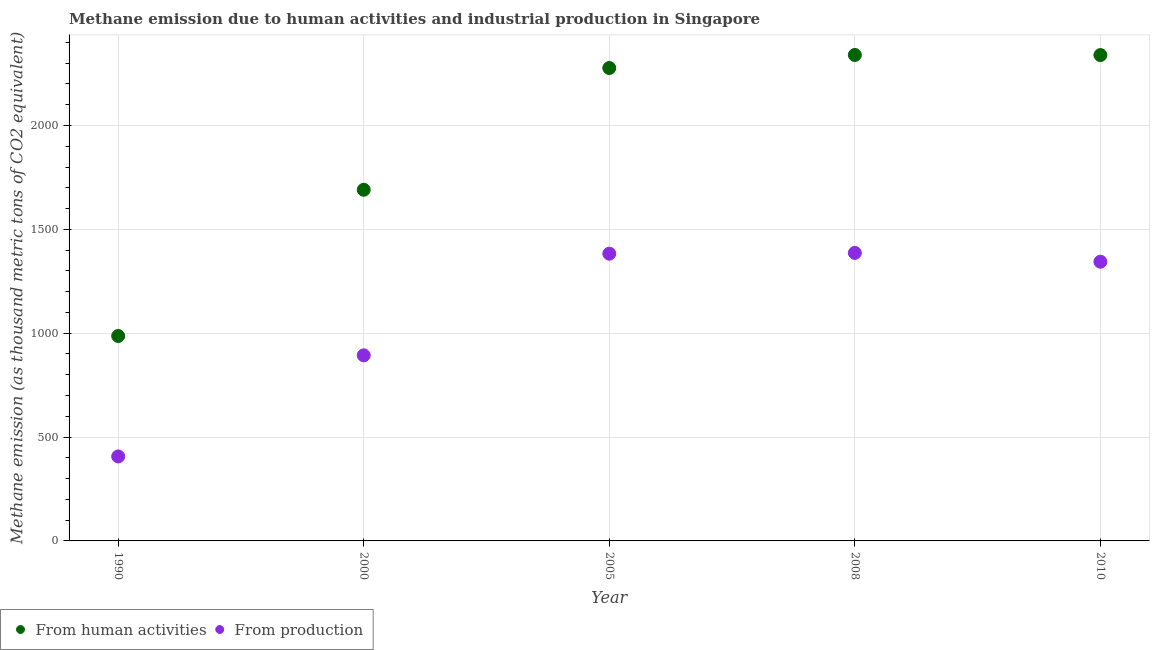What is the amount of emissions generated from industries in 2005?
Provide a short and direct response. 1383. Across all years, what is the maximum amount of emissions from human activities?
Your answer should be very brief. 2339.7. Across all years, what is the minimum amount of emissions generated from industries?
Provide a short and direct response. 406.8. What is the total amount of emissions generated from industries in the graph?
Provide a succinct answer. 5414.1. What is the difference between the amount of emissions from human activities in 2000 and that in 2008?
Offer a terse response. -649.1. What is the difference between the amount of emissions generated from industries in 2008 and the amount of emissions from human activities in 2005?
Your answer should be very brief. -890.1. What is the average amount of emissions generated from industries per year?
Your answer should be very brief. 1082.82. In the year 2000, what is the difference between the amount of emissions generated from industries and amount of emissions from human activities?
Ensure brevity in your answer.  -797.1. What is the ratio of the amount of emissions from human activities in 1990 to that in 2005?
Your answer should be compact. 0.43. Is the difference between the amount of emissions from human activities in 2008 and 2010 greater than the difference between the amount of emissions generated from industries in 2008 and 2010?
Offer a very short reply. No. What is the difference between the highest and the second highest amount of emissions generated from industries?
Your answer should be compact. 3.7. What is the difference between the highest and the lowest amount of emissions generated from industries?
Offer a very short reply. 979.9. Is the sum of the amount of emissions from human activities in 1990 and 2005 greater than the maximum amount of emissions generated from industries across all years?
Ensure brevity in your answer.  Yes. Does the amount of emissions from human activities monotonically increase over the years?
Your response must be concise. No. Is the amount of emissions from human activities strictly greater than the amount of emissions generated from industries over the years?
Give a very brief answer. Yes. Is the amount of emissions from human activities strictly less than the amount of emissions generated from industries over the years?
Ensure brevity in your answer.  No. Are the values on the major ticks of Y-axis written in scientific E-notation?
Your answer should be compact. No. Does the graph contain any zero values?
Provide a succinct answer. No. Where does the legend appear in the graph?
Offer a terse response. Bottom left. How many legend labels are there?
Keep it short and to the point. 2. How are the legend labels stacked?
Give a very brief answer. Horizontal. What is the title of the graph?
Your answer should be compact. Methane emission due to human activities and industrial production in Singapore. What is the label or title of the Y-axis?
Give a very brief answer. Methane emission (as thousand metric tons of CO2 equivalent). What is the Methane emission (as thousand metric tons of CO2 equivalent) of From human activities in 1990?
Offer a terse response. 986.7. What is the Methane emission (as thousand metric tons of CO2 equivalent) in From production in 1990?
Your answer should be compact. 406.8. What is the Methane emission (as thousand metric tons of CO2 equivalent) of From human activities in 2000?
Offer a very short reply. 1690.6. What is the Methane emission (as thousand metric tons of CO2 equivalent) of From production in 2000?
Offer a terse response. 893.5. What is the Methane emission (as thousand metric tons of CO2 equivalent) of From human activities in 2005?
Your response must be concise. 2276.8. What is the Methane emission (as thousand metric tons of CO2 equivalent) of From production in 2005?
Offer a very short reply. 1383. What is the Methane emission (as thousand metric tons of CO2 equivalent) of From human activities in 2008?
Provide a succinct answer. 2339.7. What is the Methane emission (as thousand metric tons of CO2 equivalent) in From production in 2008?
Your response must be concise. 1386.7. What is the Methane emission (as thousand metric tons of CO2 equivalent) in From human activities in 2010?
Keep it short and to the point. 2339.1. What is the Methane emission (as thousand metric tons of CO2 equivalent) of From production in 2010?
Offer a terse response. 1344.1. Across all years, what is the maximum Methane emission (as thousand metric tons of CO2 equivalent) of From human activities?
Give a very brief answer. 2339.7. Across all years, what is the maximum Methane emission (as thousand metric tons of CO2 equivalent) of From production?
Give a very brief answer. 1386.7. Across all years, what is the minimum Methane emission (as thousand metric tons of CO2 equivalent) of From human activities?
Make the answer very short. 986.7. Across all years, what is the minimum Methane emission (as thousand metric tons of CO2 equivalent) of From production?
Make the answer very short. 406.8. What is the total Methane emission (as thousand metric tons of CO2 equivalent) of From human activities in the graph?
Provide a short and direct response. 9632.9. What is the total Methane emission (as thousand metric tons of CO2 equivalent) in From production in the graph?
Ensure brevity in your answer.  5414.1. What is the difference between the Methane emission (as thousand metric tons of CO2 equivalent) in From human activities in 1990 and that in 2000?
Provide a succinct answer. -703.9. What is the difference between the Methane emission (as thousand metric tons of CO2 equivalent) of From production in 1990 and that in 2000?
Ensure brevity in your answer.  -486.7. What is the difference between the Methane emission (as thousand metric tons of CO2 equivalent) of From human activities in 1990 and that in 2005?
Your answer should be compact. -1290.1. What is the difference between the Methane emission (as thousand metric tons of CO2 equivalent) in From production in 1990 and that in 2005?
Keep it short and to the point. -976.2. What is the difference between the Methane emission (as thousand metric tons of CO2 equivalent) of From human activities in 1990 and that in 2008?
Make the answer very short. -1353. What is the difference between the Methane emission (as thousand metric tons of CO2 equivalent) in From production in 1990 and that in 2008?
Keep it short and to the point. -979.9. What is the difference between the Methane emission (as thousand metric tons of CO2 equivalent) in From human activities in 1990 and that in 2010?
Offer a very short reply. -1352.4. What is the difference between the Methane emission (as thousand metric tons of CO2 equivalent) in From production in 1990 and that in 2010?
Offer a very short reply. -937.3. What is the difference between the Methane emission (as thousand metric tons of CO2 equivalent) in From human activities in 2000 and that in 2005?
Offer a terse response. -586.2. What is the difference between the Methane emission (as thousand metric tons of CO2 equivalent) in From production in 2000 and that in 2005?
Keep it short and to the point. -489.5. What is the difference between the Methane emission (as thousand metric tons of CO2 equivalent) in From human activities in 2000 and that in 2008?
Your answer should be very brief. -649.1. What is the difference between the Methane emission (as thousand metric tons of CO2 equivalent) in From production in 2000 and that in 2008?
Give a very brief answer. -493.2. What is the difference between the Methane emission (as thousand metric tons of CO2 equivalent) of From human activities in 2000 and that in 2010?
Your response must be concise. -648.5. What is the difference between the Methane emission (as thousand metric tons of CO2 equivalent) of From production in 2000 and that in 2010?
Keep it short and to the point. -450.6. What is the difference between the Methane emission (as thousand metric tons of CO2 equivalent) in From human activities in 2005 and that in 2008?
Provide a succinct answer. -62.9. What is the difference between the Methane emission (as thousand metric tons of CO2 equivalent) in From human activities in 2005 and that in 2010?
Provide a short and direct response. -62.3. What is the difference between the Methane emission (as thousand metric tons of CO2 equivalent) of From production in 2005 and that in 2010?
Provide a succinct answer. 38.9. What is the difference between the Methane emission (as thousand metric tons of CO2 equivalent) in From human activities in 2008 and that in 2010?
Give a very brief answer. 0.6. What is the difference between the Methane emission (as thousand metric tons of CO2 equivalent) of From production in 2008 and that in 2010?
Your answer should be very brief. 42.6. What is the difference between the Methane emission (as thousand metric tons of CO2 equivalent) of From human activities in 1990 and the Methane emission (as thousand metric tons of CO2 equivalent) of From production in 2000?
Offer a terse response. 93.2. What is the difference between the Methane emission (as thousand metric tons of CO2 equivalent) in From human activities in 1990 and the Methane emission (as thousand metric tons of CO2 equivalent) in From production in 2005?
Provide a succinct answer. -396.3. What is the difference between the Methane emission (as thousand metric tons of CO2 equivalent) in From human activities in 1990 and the Methane emission (as thousand metric tons of CO2 equivalent) in From production in 2008?
Offer a terse response. -400. What is the difference between the Methane emission (as thousand metric tons of CO2 equivalent) in From human activities in 1990 and the Methane emission (as thousand metric tons of CO2 equivalent) in From production in 2010?
Provide a succinct answer. -357.4. What is the difference between the Methane emission (as thousand metric tons of CO2 equivalent) in From human activities in 2000 and the Methane emission (as thousand metric tons of CO2 equivalent) in From production in 2005?
Offer a terse response. 307.6. What is the difference between the Methane emission (as thousand metric tons of CO2 equivalent) of From human activities in 2000 and the Methane emission (as thousand metric tons of CO2 equivalent) of From production in 2008?
Your response must be concise. 303.9. What is the difference between the Methane emission (as thousand metric tons of CO2 equivalent) of From human activities in 2000 and the Methane emission (as thousand metric tons of CO2 equivalent) of From production in 2010?
Keep it short and to the point. 346.5. What is the difference between the Methane emission (as thousand metric tons of CO2 equivalent) of From human activities in 2005 and the Methane emission (as thousand metric tons of CO2 equivalent) of From production in 2008?
Your answer should be compact. 890.1. What is the difference between the Methane emission (as thousand metric tons of CO2 equivalent) of From human activities in 2005 and the Methane emission (as thousand metric tons of CO2 equivalent) of From production in 2010?
Offer a terse response. 932.7. What is the difference between the Methane emission (as thousand metric tons of CO2 equivalent) of From human activities in 2008 and the Methane emission (as thousand metric tons of CO2 equivalent) of From production in 2010?
Make the answer very short. 995.6. What is the average Methane emission (as thousand metric tons of CO2 equivalent) of From human activities per year?
Give a very brief answer. 1926.58. What is the average Methane emission (as thousand metric tons of CO2 equivalent) of From production per year?
Your response must be concise. 1082.82. In the year 1990, what is the difference between the Methane emission (as thousand metric tons of CO2 equivalent) of From human activities and Methane emission (as thousand metric tons of CO2 equivalent) of From production?
Your response must be concise. 579.9. In the year 2000, what is the difference between the Methane emission (as thousand metric tons of CO2 equivalent) in From human activities and Methane emission (as thousand metric tons of CO2 equivalent) in From production?
Your answer should be very brief. 797.1. In the year 2005, what is the difference between the Methane emission (as thousand metric tons of CO2 equivalent) in From human activities and Methane emission (as thousand metric tons of CO2 equivalent) in From production?
Ensure brevity in your answer.  893.8. In the year 2008, what is the difference between the Methane emission (as thousand metric tons of CO2 equivalent) in From human activities and Methane emission (as thousand metric tons of CO2 equivalent) in From production?
Make the answer very short. 953. In the year 2010, what is the difference between the Methane emission (as thousand metric tons of CO2 equivalent) in From human activities and Methane emission (as thousand metric tons of CO2 equivalent) in From production?
Make the answer very short. 995. What is the ratio of the Methane emission (as thousand metric tons of CO2 equivalent) of From human activities in 1990 to that in 2000?
Provide a succinct answer. 0.58. What is the ratio of the Methane emission (as thousand metric tons of CO2 equivalent) in From production in 1990 to that in 2000?
Offer a very short reply. 0.46. What is the ratio of the Methane emission (as thousand metric tons of CO2 equivalent) in From human activities in 1990 to that in 2005?
Keep it short and to the point. 0.43. What is the ratio of the Methane emission (as thousand metric tons of CO2 equivalent) in From production in 1990 to that in 2005?
Ensure brevity in your answer.  0.29. What is the ratio of the Methane emission (as thousand metric tons of CO2 equivalent) in From human activities in 1990 to that in 2008?
Offer a very short reply. 0.42. What is the ratio of the Methane emission (as thousand metric tons of CO2 equivalent) in From production in 1990 to that in 2008?
Ensure brevity in your answer.  0.29. What is the ratio of the Methane emission (as thousand metric tons of CO2 equivalent) of From human activities in 1990 to that in 2010?
Ensure brevity in your answer.  0.42. What is the ratio of the Methane emission (as thousand metric tons of CO2 equivalent) of From production in 1990 to that in 2010?
Provide a short and direct response. 0.3. What is the ratio of the Methane emission (as thousand metric tons of CO2 equivalent) of From human activities in 2000 to that in 2005?
Keep it short and to the point. 0.74. What is the ratio of the Methane emission (as thousand metric tons of CO2 equivalent) in From production in 2000 to that in 2005?
Offer a very short reply. 0.65. What is the ratio of the Methane emission (as thousand metric tons of CO2 equivalent) in From human activities in 2000 to that in 2008?
Your response must be concise. 0.72. What is the ratio of the Methane emission (as thousand metric tons of CO2 equivalent) in From production in 2000 to that in 2008?
Give a very brief answer. 0.64. What is the ratio of the Methane emission (as thousand metric tons of CO2 equivalent) in From human activities in 2000 to that in 2010?
Provide a succinct answer. 0.72. What is the ratio of the Methane emission (as thousand metric tons of CO2 equivalent) of From production in 2000 to that in 2010?
Keep it short and to the point. 0.66. What is the ratio of the Methane emission (as thousand metric tons of CO2 equivalent) in From human activities in 2005 to that in 2008?
Provide a succinct answer. 0.97. What is the ratio of the Methane emission (as thousand metric tons of CO2 equivalent) in From human activities in 2005 to that in 2010?
Provide a succinct answer. 0.97. What is the ratio of the Methane emission (as thousand metric tons of CO2 equivalent) in From production in 2005 to that in 2010?
Make the answer very short. 1.03. What is the ratio of the Methane emission (as thousand metric tons of CO2 equivalent) of From human activities in 2008 to that in 2010?
Keep it short and to the point. 1. What is the ratio of the Methane emission (as thousand metric tons of CO2 equivalent) of From production in 2008 to that in 2010?
Offer a terse response. 1.03. What is the difference between the highest and the second highest Methane emission (as thousand metric tons of CO2 equivalent) of From human activities?
Provide a short and direct response. 0.6. What is the difference between the highest and the second highest Methane emission (as thousand metric tons of CO2 equivalent) of From production?
Offer a terse response. 3.7. What is the difference between the highest and the lowest Methane emission (as thousand metric tons of CO2 equivalent) in From human activities?
Your response must be concise. 1353. What is the difference between the highest and the lowest Methane emission (as thousand metric tons of CO2 equivalent) in From production?
Make the answer very short. 979.9. 